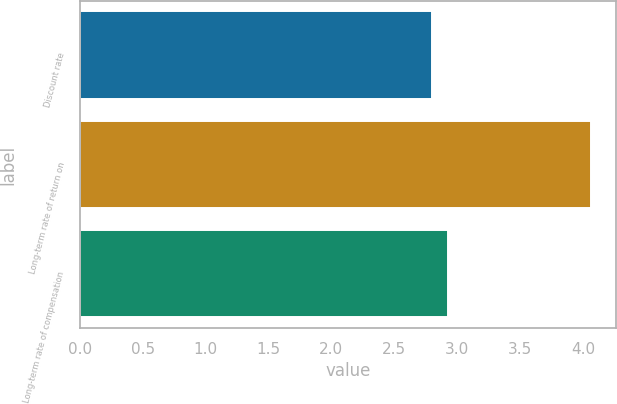<chart> <loc_0><loc_0><loc_500><loc_500><bar_chart><fcel>Discount rate<fcel>Long-term rate of return on<fcel>Long-term rate of compensation<nl><fcel>2.8<fcel>4.06<fcel>2.93<nl></chart> 